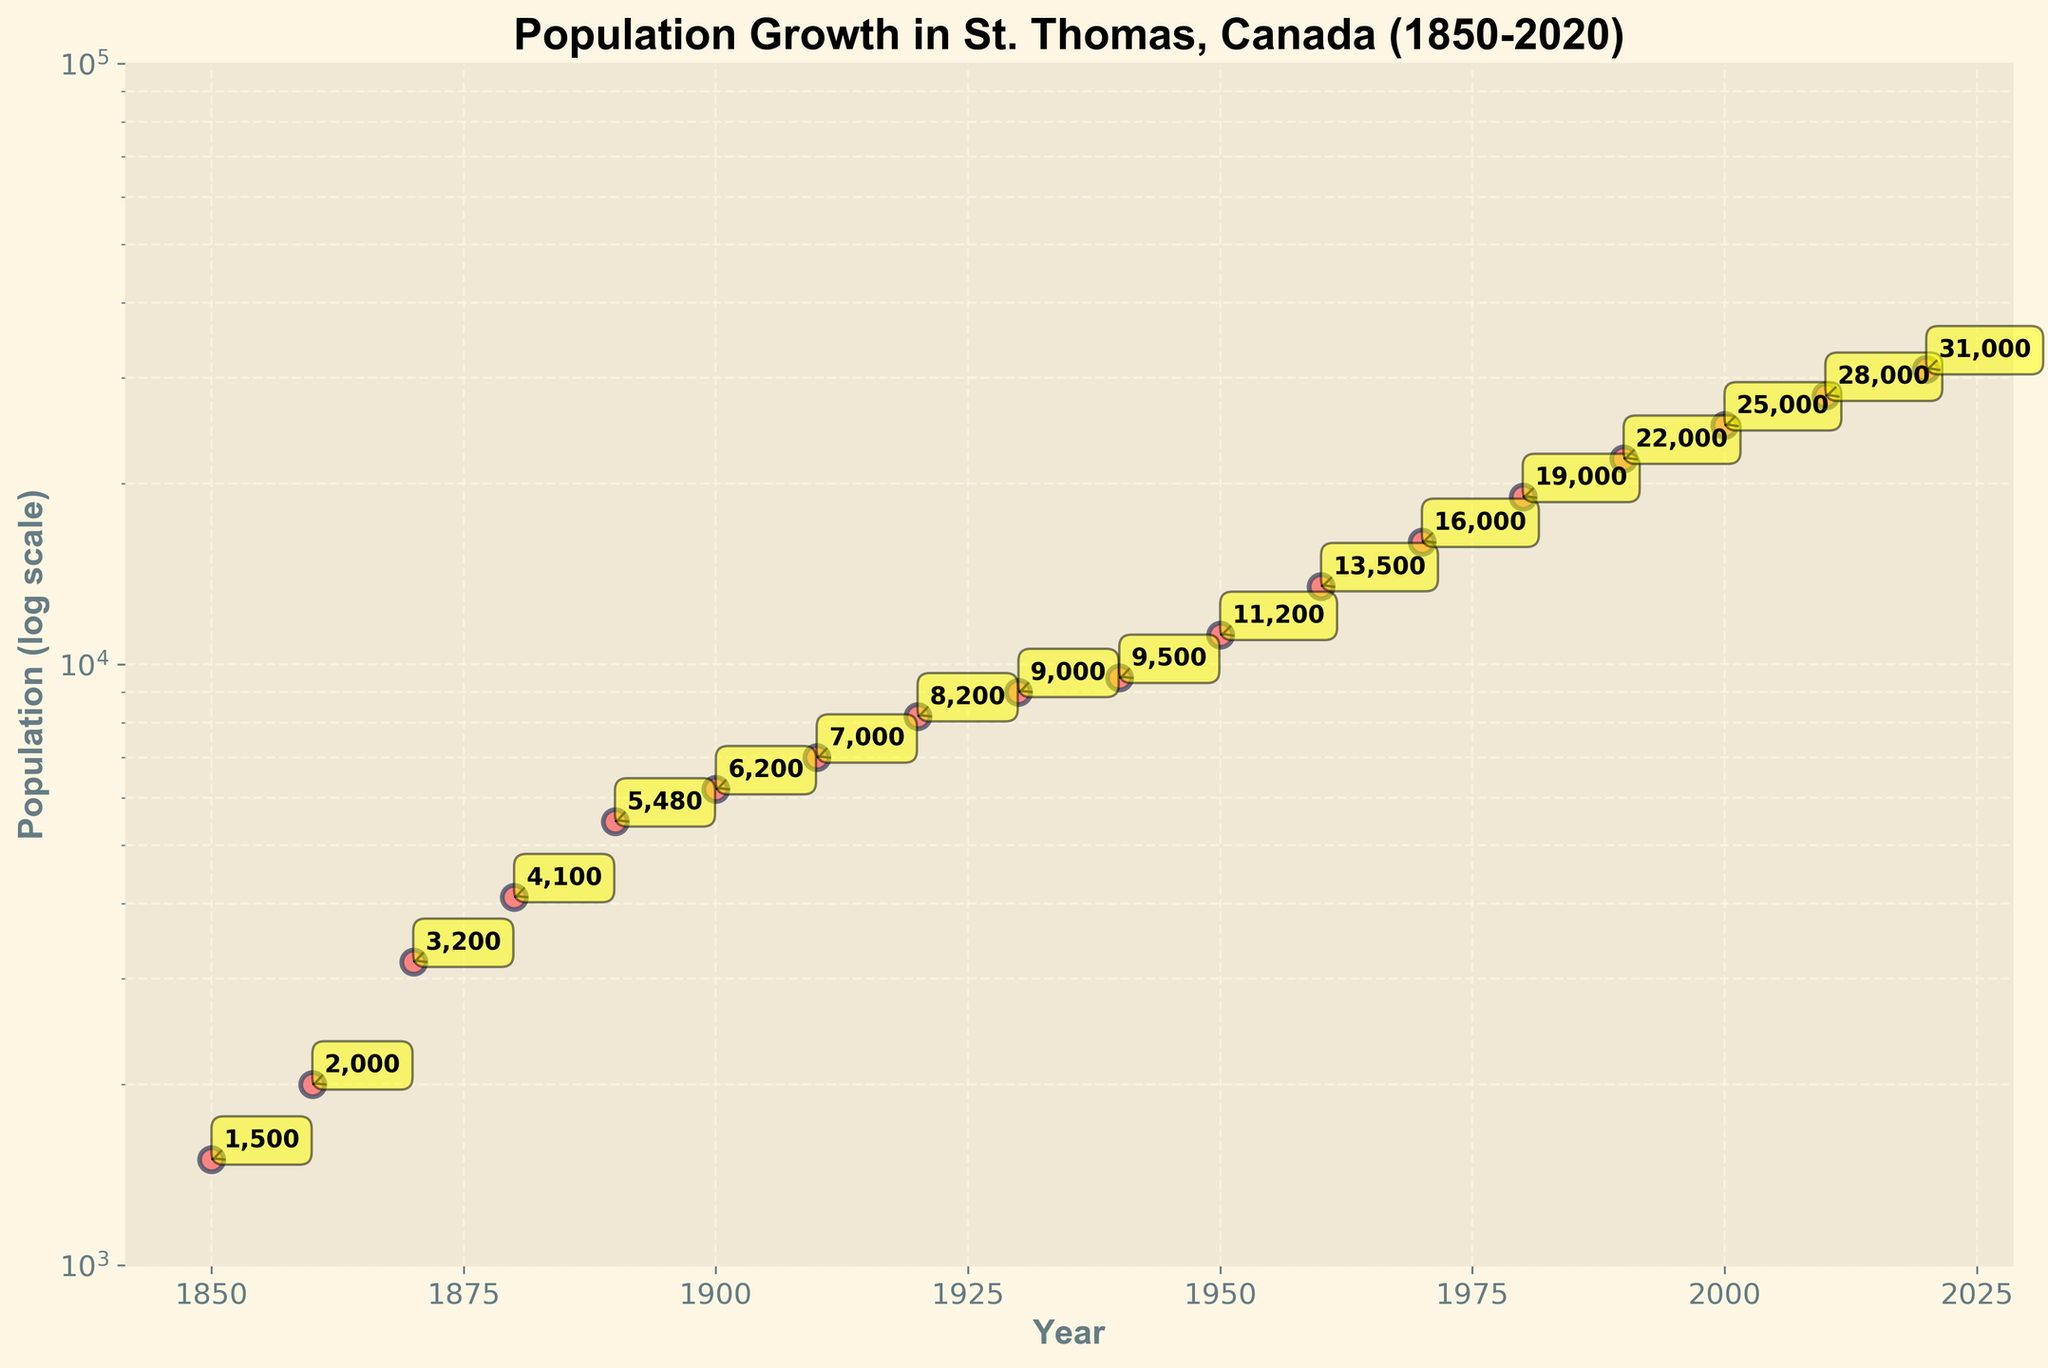How many years are displayed on the x-axis? There are a total of 18 data points displayed on the x-axis, each representing a different year from 1850 to 2020
Answer: 18 What is the title of the figure? The title of the figure is located at the top and reads "Population Growth in St. Thomas, Canada (1850-2020)"
Answer: Population Growth in St. Thomas, Canada (1850-2020) What is the population value in the year 1900? By looking at the data point corresponding to the year 1900, we can see the population value is given as 6,200
Answer: 6,200 How many times has the population doubled between 1850 and 2020? Starting from 1,500 in 1850, the population doubles approximately three times by reaching approximately 3,000 (3,200) before 1870, 6,000 (6,200) before 1900, and 12,000 (13,500) before 1960. Subsequent years continue to show growth, but not exact doubling.
Answer: 3 Which decade experienced the highest population growth? By comparing the population from one decade to the next, the largest jump in population is observed between 1940 (9,500) and 1950 (11,200), a difference of 1,700
Answer: 1940 to 1950 What is the log scale y-axis range? The y-axis range is set between 1,000 and 100,000 on a logarithmic scale, as seen from the axis ticks and labels
Answer: 1,000 to 100,000 By what factor did the population increase from 1900 to 2000? The population in 1900 was 6,200, and in 2000 it was 25,000. The factor increase can be calculated as 25,000 / 6,200 ≈ 4.03
Answer: 4.03 What is the trend observed in the scatter plot? The scatter plot shows an upward trend indicating that the population of St. Thomas, Canada has consistently increased from 1850 to 2020
Answer: Upward trend Compare the population growth between the 1800s and the 1900s. In the 1800s (1850 to 1900), the population grew from 1,500 to 6,200, an increase of 4,700. In the 1900s (1900 to 2000), it grew from 6,200 to 25,000, an increase of 18,800. Thus, the growth during the 1900s was significantly higher
Answer: The growth was higher in the 1900s At approximately what year did the population reach 10,000? Observing the data points, the population crosses 10,000 between 1940 and 1950, specifically around 1950 when it is 11,200
Answer: Around 1950 